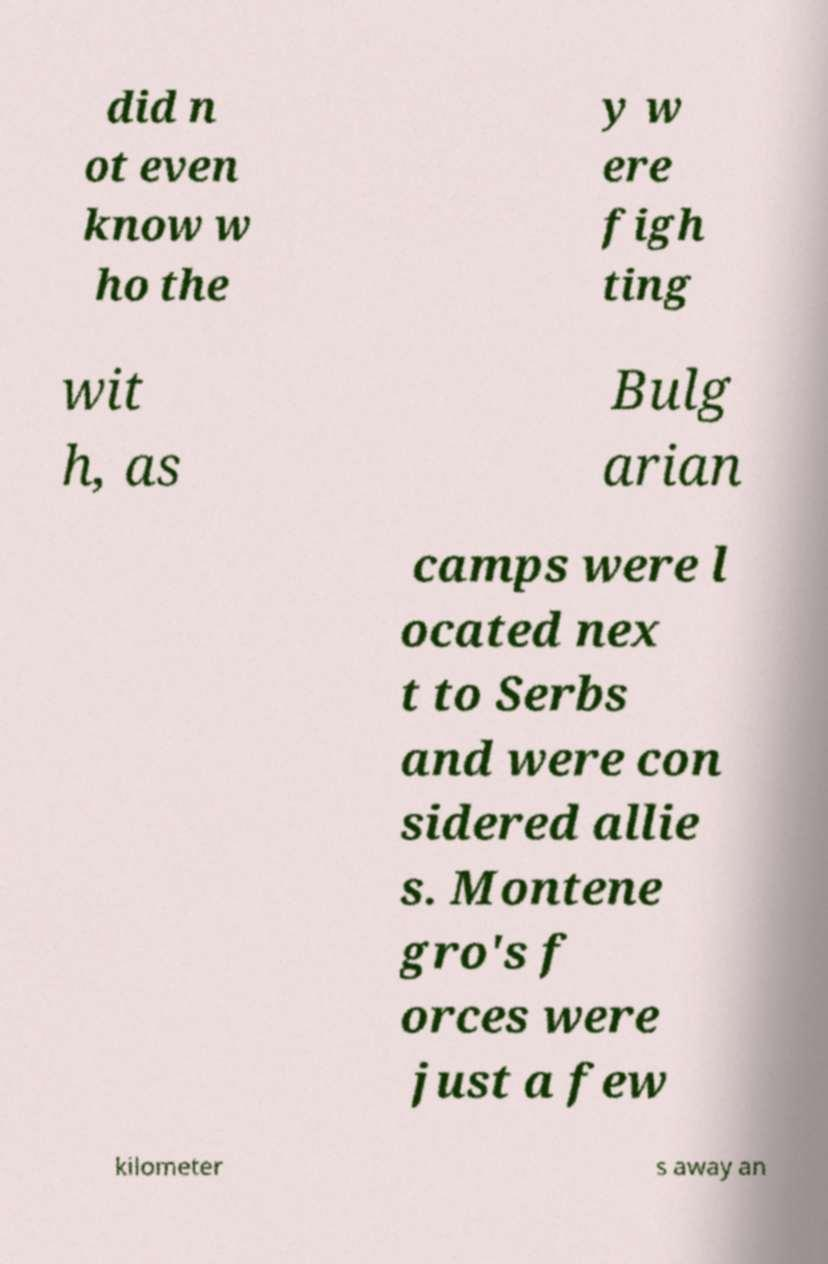Could you assist in decoding the text presented in this image and type it out clearly? did n ot even know w ho the y w ere figh ting wit h, as Bulg arian camps were l ocated nex t to Serbs and were con sidered allie s. Montene gro's f orces were just a few kilometer s away an 